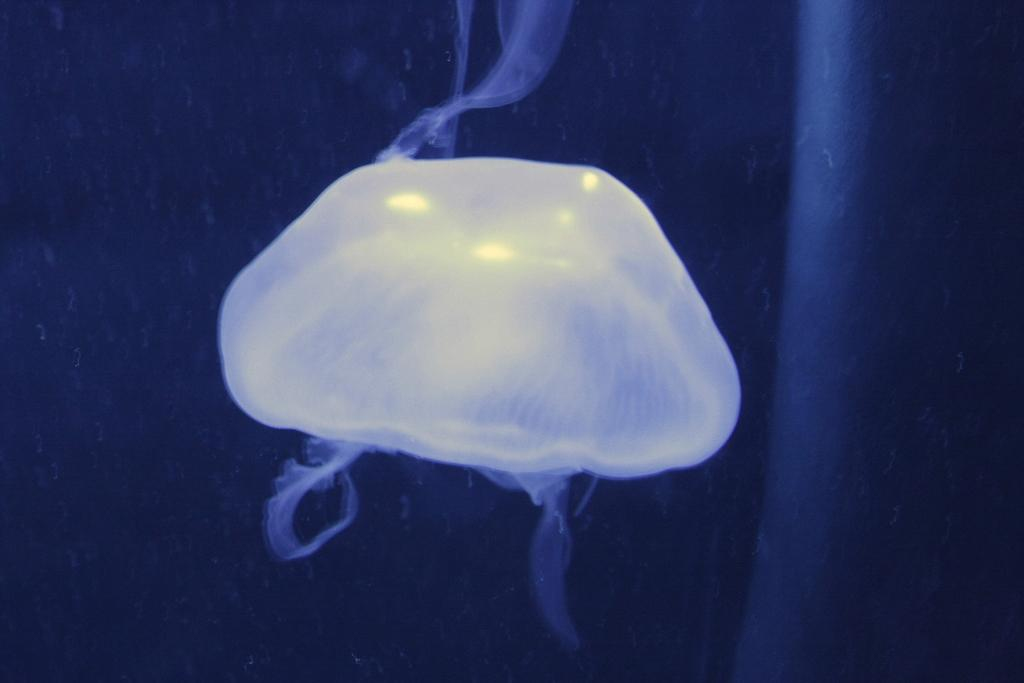What is the main subject of the picture? The main subject of the picture is a jellyfish. What can be observed about the background of the image? The background of the image is dark. What type of hands can be seen holding the jellyfish in the image? There are no hands or any human presence in the image; it features a jellyfish in a dark background. What emotion does the jellyfish appear to be experiencing in the image? The jellyfish is an invertebrate marine animal and does not experience emotions like shame. 